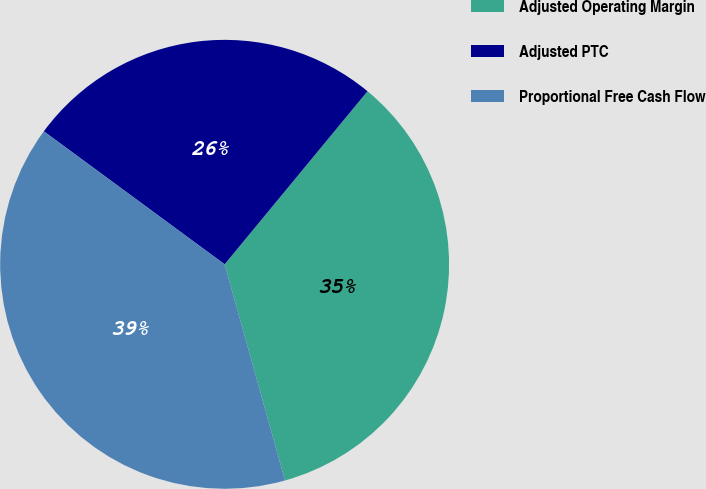<chart> <loc_0><loc_0><loc_500><loc_500><pie_chart><fcel>Adjusted Operating Margin<fcel>Adjusted PTC<fcel>Proportional Free Cash Flow<nl><fcel>34.68%<fcel>25.89%<fcel>39.43%<nl></chart> 